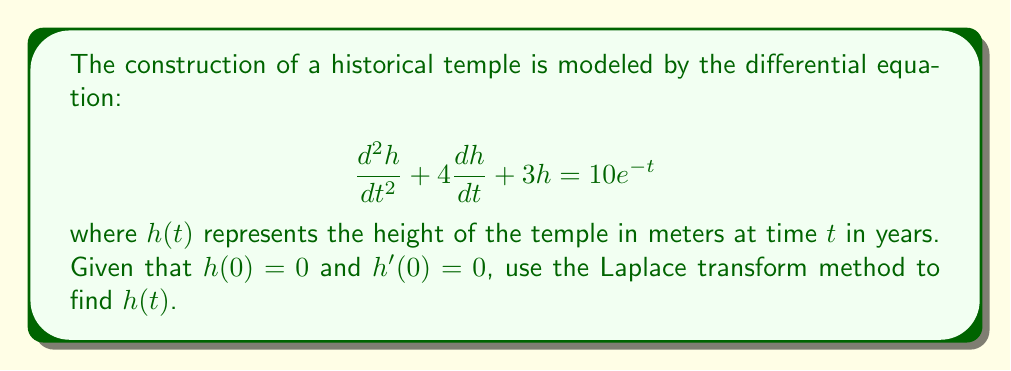Give your solution to this math problem. Let's solve this step-by-step using the Laplace transform method:

1) Take the Laplace transform of both sides of the equation:
   $$\mathcal{L}\{\frac{d^2h}{dt^2} + 4\frac{dh}{dt} + 3h\} = \mathcal{L}\{10e^{-t}\}$$

2) Using Laplace transform properties:
   $$s^2H(s) - sh(0) - h'(0) + 4[sH(s) - h(0)] + 3H(s) = \frac{10}{s+1}$$

3) Substitute the initial conditions $h(0) = 0$ and $h'(0) = 0$:
   $$s^2H(s) + 4sH(s) + 3H(s) = \frac{10}{s+1}$$

4) Factor out $H(s)$:
   $$H(s)(s^2 + 4s + 3) = \frac{10}{s+1}$$

5) Solve for $H(s)$:
   $$H(s) = \frac{10}{(s+1)(s^2 + 4s + 3)}$$

6) Use partial fraction decomposition:
   $$H(s) = \frac{A}{s+1} + \frac{Bs+C}{s^2 + 4s + 3}$$

7) Solve for $A$, $B$, and $C$:
   $A = \frac{10}{6}$, $B = -\frac{5}{3}$, $C = -\frac{10}{3}$

8) Rewrite $H(s)$:
   $$H(s) = \frac{10/6}{s+1} - \frac{5/3(s+2)}{(s+1)^2 + 2^2}$$

9) Take the inverse Laplace transform:
   $$h(t) = \frac{10}{6}e^{-t} - \frac{5}{3}e^{-t}(\cos(2t) + \sin(2t))$$

10) Simplify:
    $$h(t) = \frac{5}{3}e^{-t} - \frac{5}{3}e^{-t}(\cos(2t) + \sin(2t))$$
Answer: $$h(t) = \frac{5}{3}e^{-t}(1 - \cos(2t) - \sin(2t))$$ 